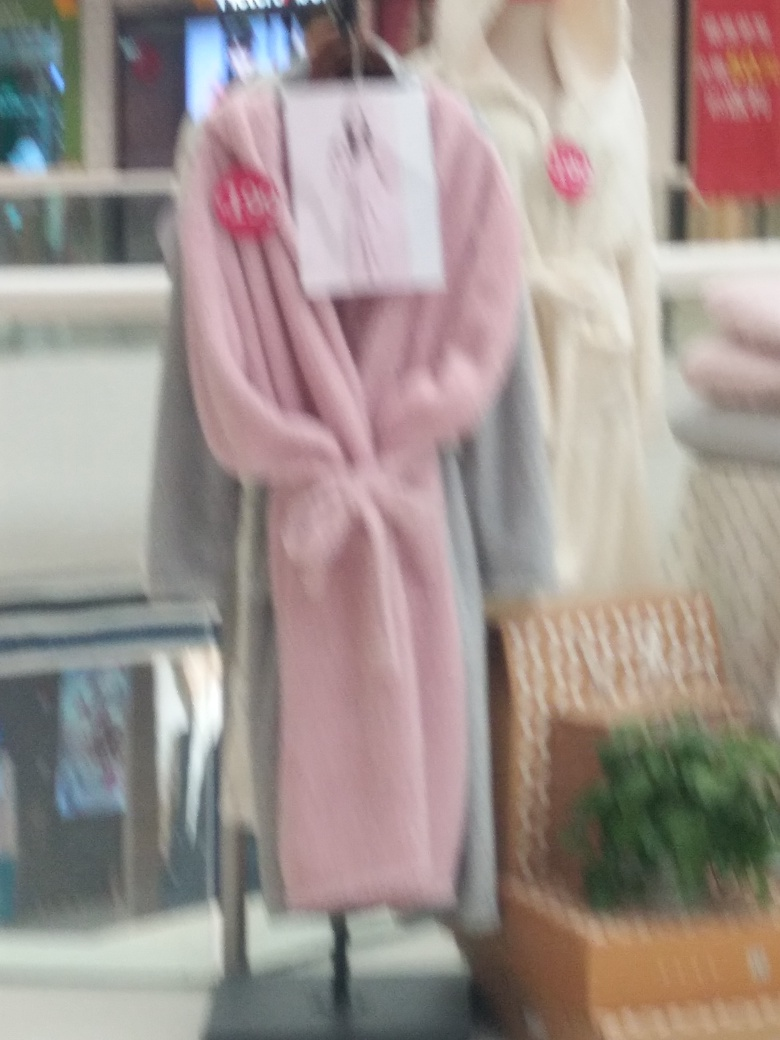Are there any quality issues with this image? Yes, the image is notably blurry, making it difficult to discern fine details. Additionally, the focus appears to be off, which could be due to camera movement or improper focus settings at the time of capture. 